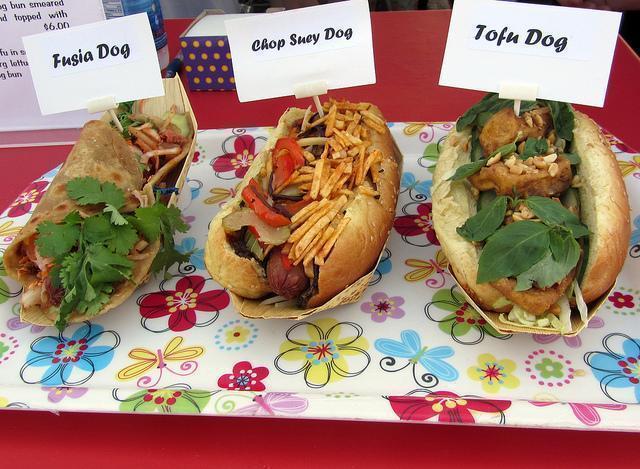What would a vegetarian order from this restaurant?
Choose the correct response, then elucidate: 'Answer: answer
Rationale: rationale.'
Options: Monte cristo, hamburger, reuben, tofu dog. Answer: tofu dog.
Rationale: The tofu dog is available. 